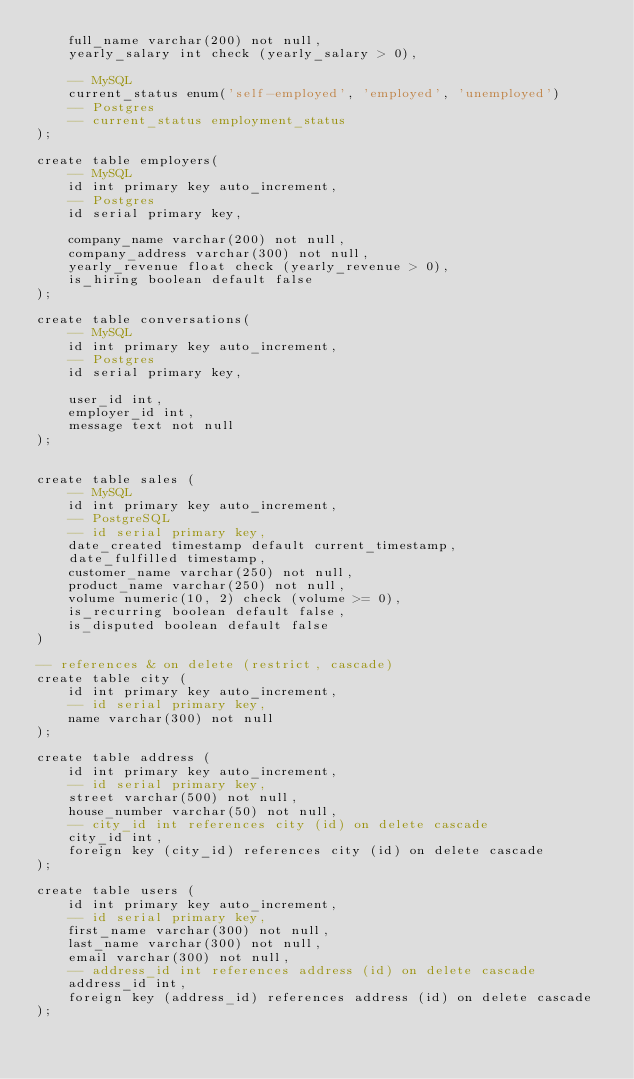<code> <loc_0><loc_0><loc_500><loc_500><_SQL_>    full_name varchar(200) not null,
    yearly_salary int check (yearly_salary > 0),
    
    -- MySQL
    current_status enum('self-employed', 'employed', 'unemployed')
    -- Postgres
    -- current_status employment_status
);

create table employers(
    -- MySQL
    id int primary key auto_increment,
    -- Postgres
    id serial primary key,
    
    company_name varchar(200) not null,
    company_address varchar(300) not null,
    yearly_revenue float check (yearly_revenue > 0),
    is_hiring boolean default false
);

create table conversations(
    -- MySQL
    id int primary key auto_increment,
    -- Postgres
    id serial primary key,
    
    user_id int,
    employer_id int,
    message text not null
);


create table sales (
    -- MySQL
    id int primary key auto_increment,
    -- PostgreSQL
    -- id serial primary key,
    date_created timestamp default current_timestamp,
    date_fulfilled timestamp,
    customer_name varchar(250) not null,
    product_name varchar(250) not null,
    volume numeric(10, 2) check (volume >= 0),
    is_recurring boolean default false,
    is_disputed boolean default false
)

-- references & on delete (restrict, cascade)
create table city (
    id int primary key auto_increment,
    -- id serial primary key,
    name varchar(300) not null
);

create table address (
    id int primary key auto_increment,
    -- id serial primary key,
    street varchar(500) not null,
    house_number varchar(50) not null,
    -- city_id int references city (id) on delete cascade
    city_id int,
    foreign key (city_id) references city (id) on delete cascade
);

create table users (
    id int primary key auto_increment,
    -- id serial primary key,
    first_name varchar(300) not null,
    last_name varchar(300) not null,
    email varchar(300) not null,
    -- address_id int references address (id) on delete cascade
    address_id int,
    foreign key (address_id) references address (id) on delete cascade
);</code> 